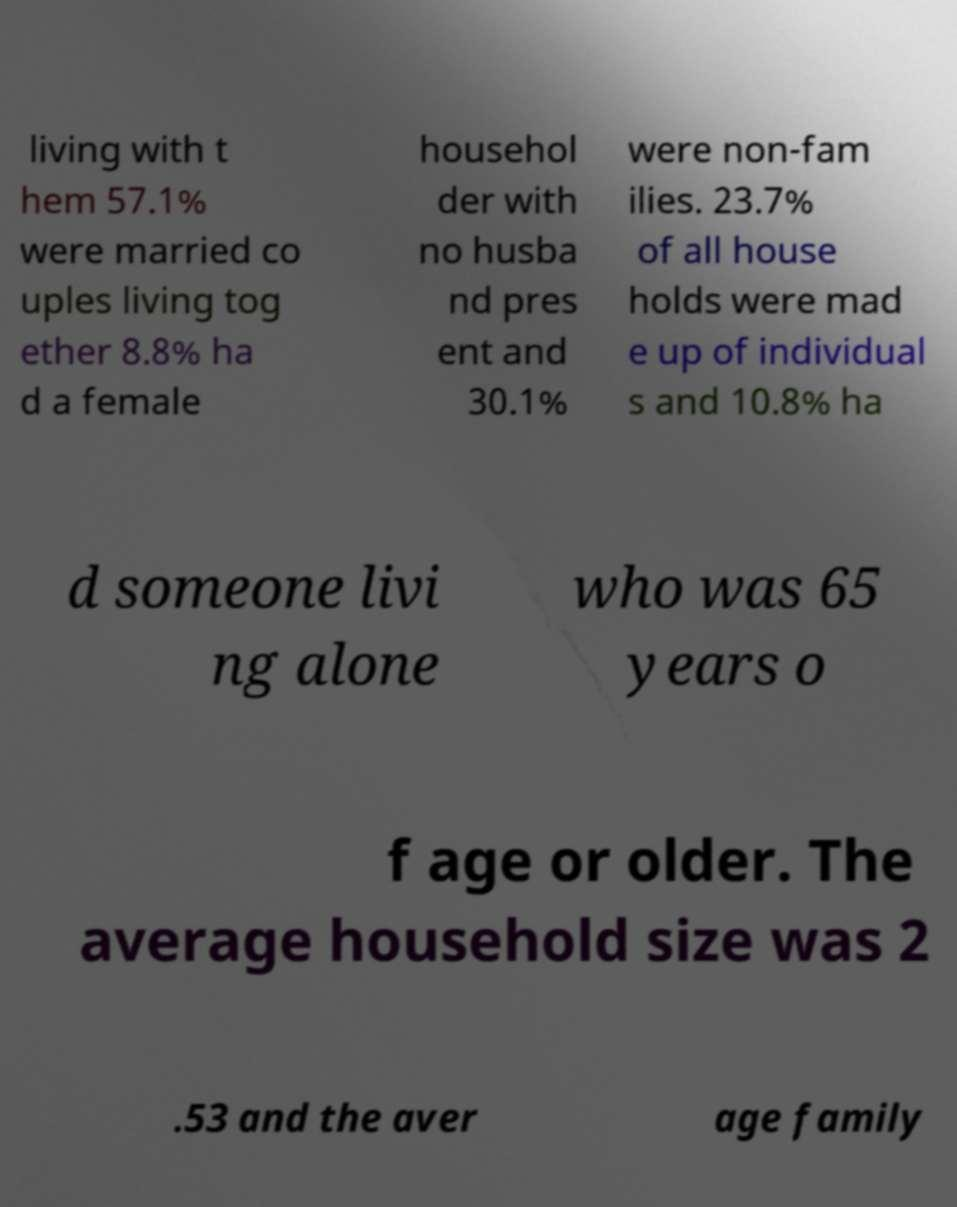For documentation purposes, I need the text within this image transcribed. Could you provide that? living with t hem 57.1% were married co uples living tog ether 8.8% ha d a female househol der with no husba nd pres ent and 30.1% were non-fam ilies. 23.7% of all house holds were mad e up of individual s and 10.8% ha d someone livi ng alone who was 65 years o f age or older. The average household size was 2 .53 and the aver age family 